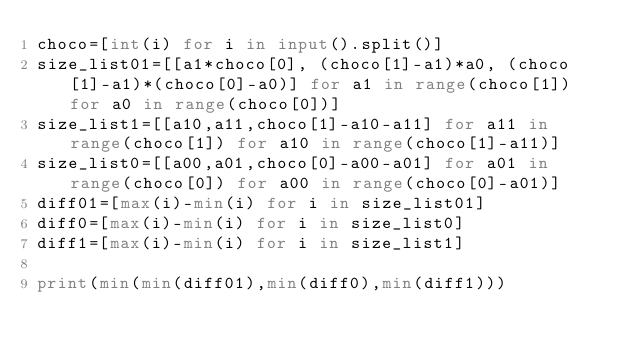<code> <loc_0><loc_0><loc_500><loc_500><_Python_>choco=[int(i) for i in input().split()]
size_list01=[[a1*choco[0], (choco[1]-a1)*a0, (choco[1]-a1)*(choco[0]-a0)] for a1 in range(choco[1]) for a0 in range(choco[0])]
size_list1=[[a10,a11,choco[1]-a10-a11] for a11 in range(choco[1]) for a10 in range(choco[1]-a11)]
size_list0=[[a00,a01,choco[0]-a00-a01] for a01 in range(choco[0]) for a00 in range(choco[0]-a01)]
diff01=[max(i)-min(i) for i in size_list01]
diff0=[max(i)-min(i) for i in size_list0]
diff1=[max(i)-min(i) for i in size_list1]

print(min(min(diff01),min(diff0),min(diff1)))
</code> 